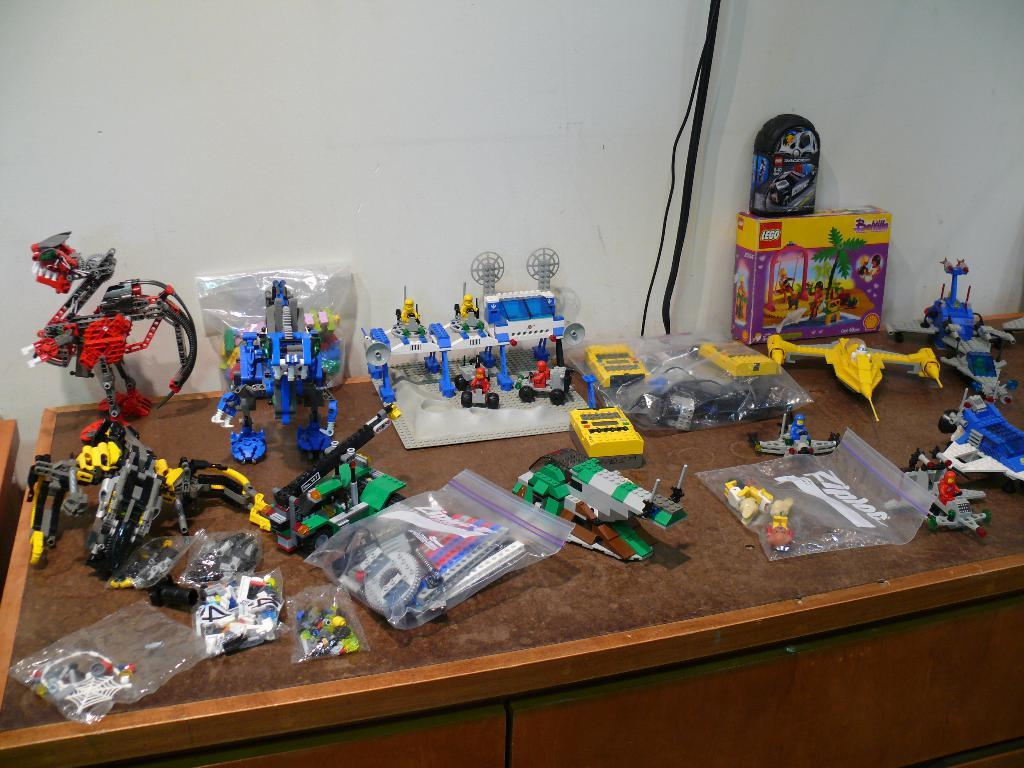What is the main piece of furniture in the image? There is a table in the image. What is placed on the table? There are toys and packets on the table. What is the background behind the table? There is a wall behind the table. What is the wall hiding? The wall is hiding wires. What is inside the packets on the table? The packets contain objects. What type of apparel is being worn by the straw in the image? There is no straw or apparel present in the image. What type of pipe can be seen connecting the toys on the table? There is no pipe connecting the toys on the table in the image. 